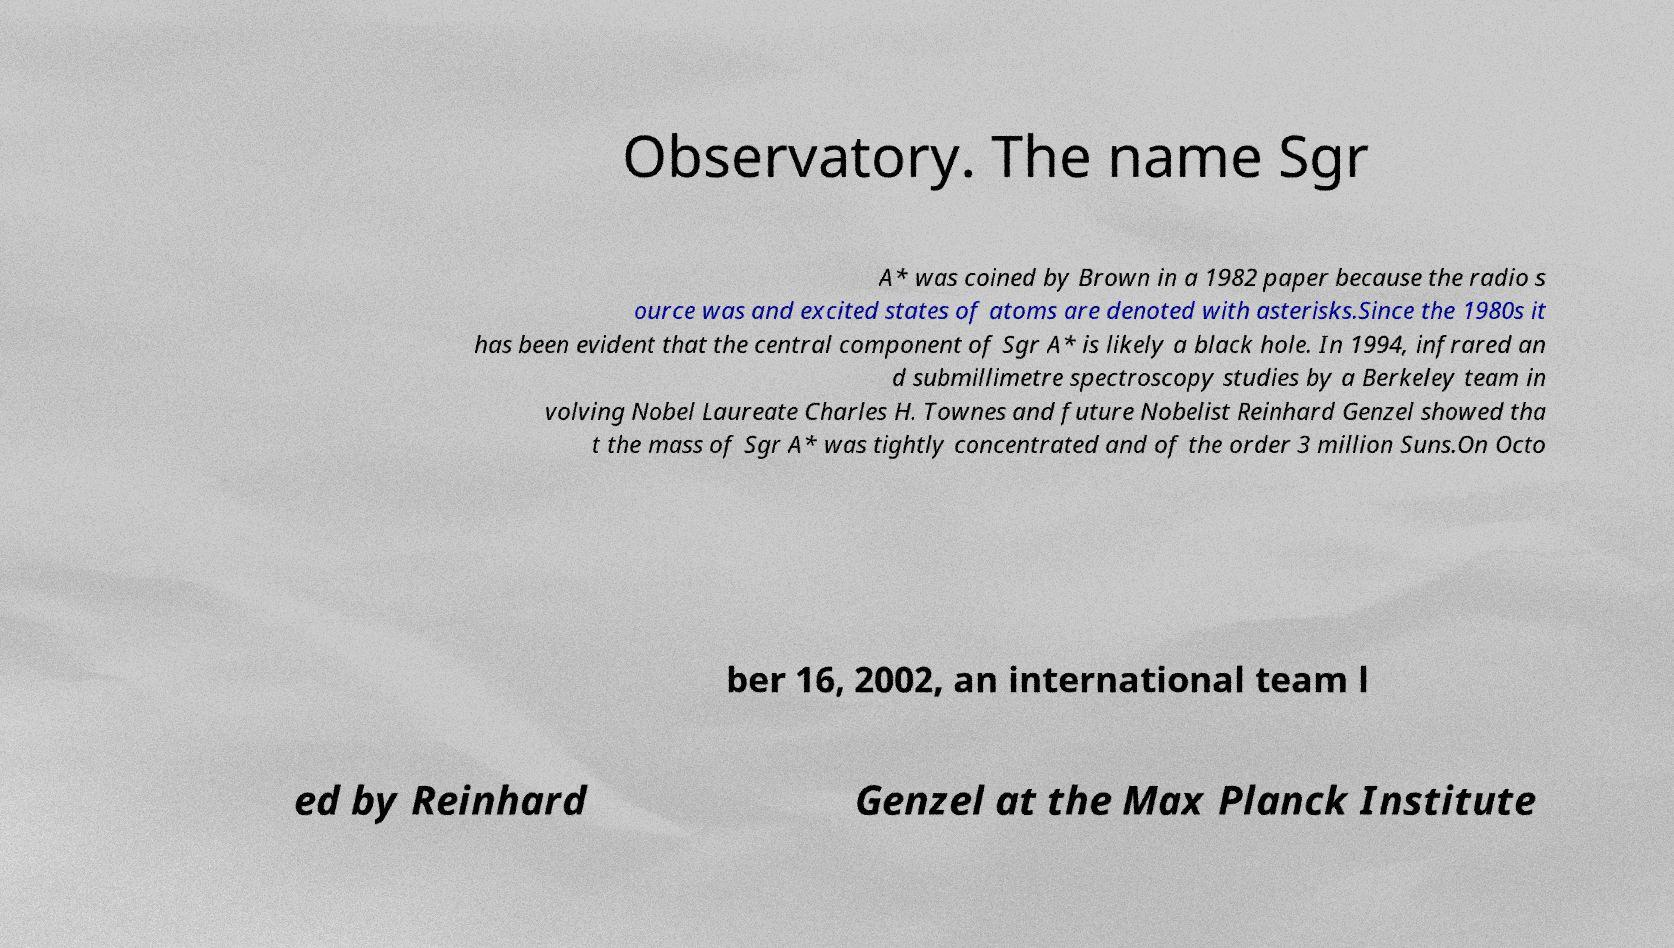I need the written content from this picture converted into text. Can you do that? Observatory. The name Sgr A* was coined by Brown in a 1982 paper because the radio s ource was and excited states of atoms are denoted with asterisks.Since the 1980s it has been evident that the central component of Sgr A* is likely a black hole. In 1994, infrared an d submillimetre spectroscopy studies by a Berkeley team in volving Nobel Laureate Charles H. Townes and future Nobelist Reinhard Genzel showed tha t the mass of Sgr A* was tightly concentrated and of the order 3 million Suns.On Octo ber 16, 2002, an international team l ed by Reinhard Genzel at the Max Planck Institute 